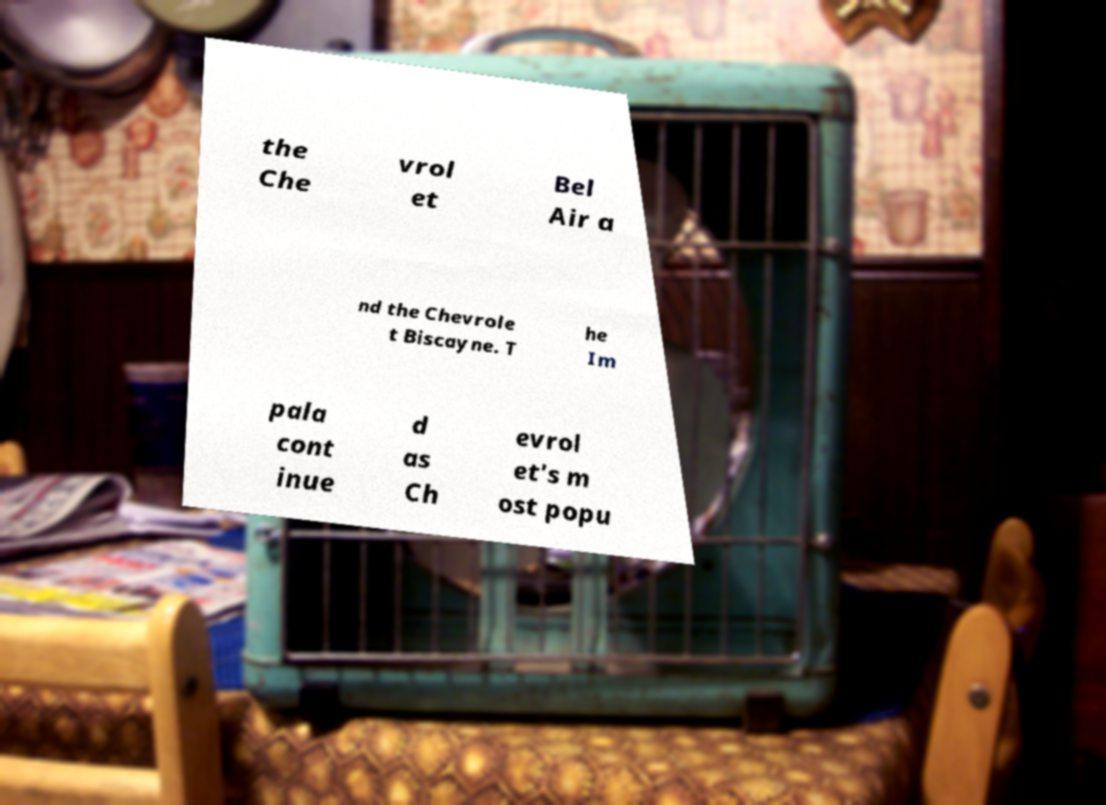Please identify and transcribe the text found in this image. the Che vrol et Bel Air a nd the Chevrole t Biscayne. T he Im pala cont inue d as Ch evrol et's m ost popu 